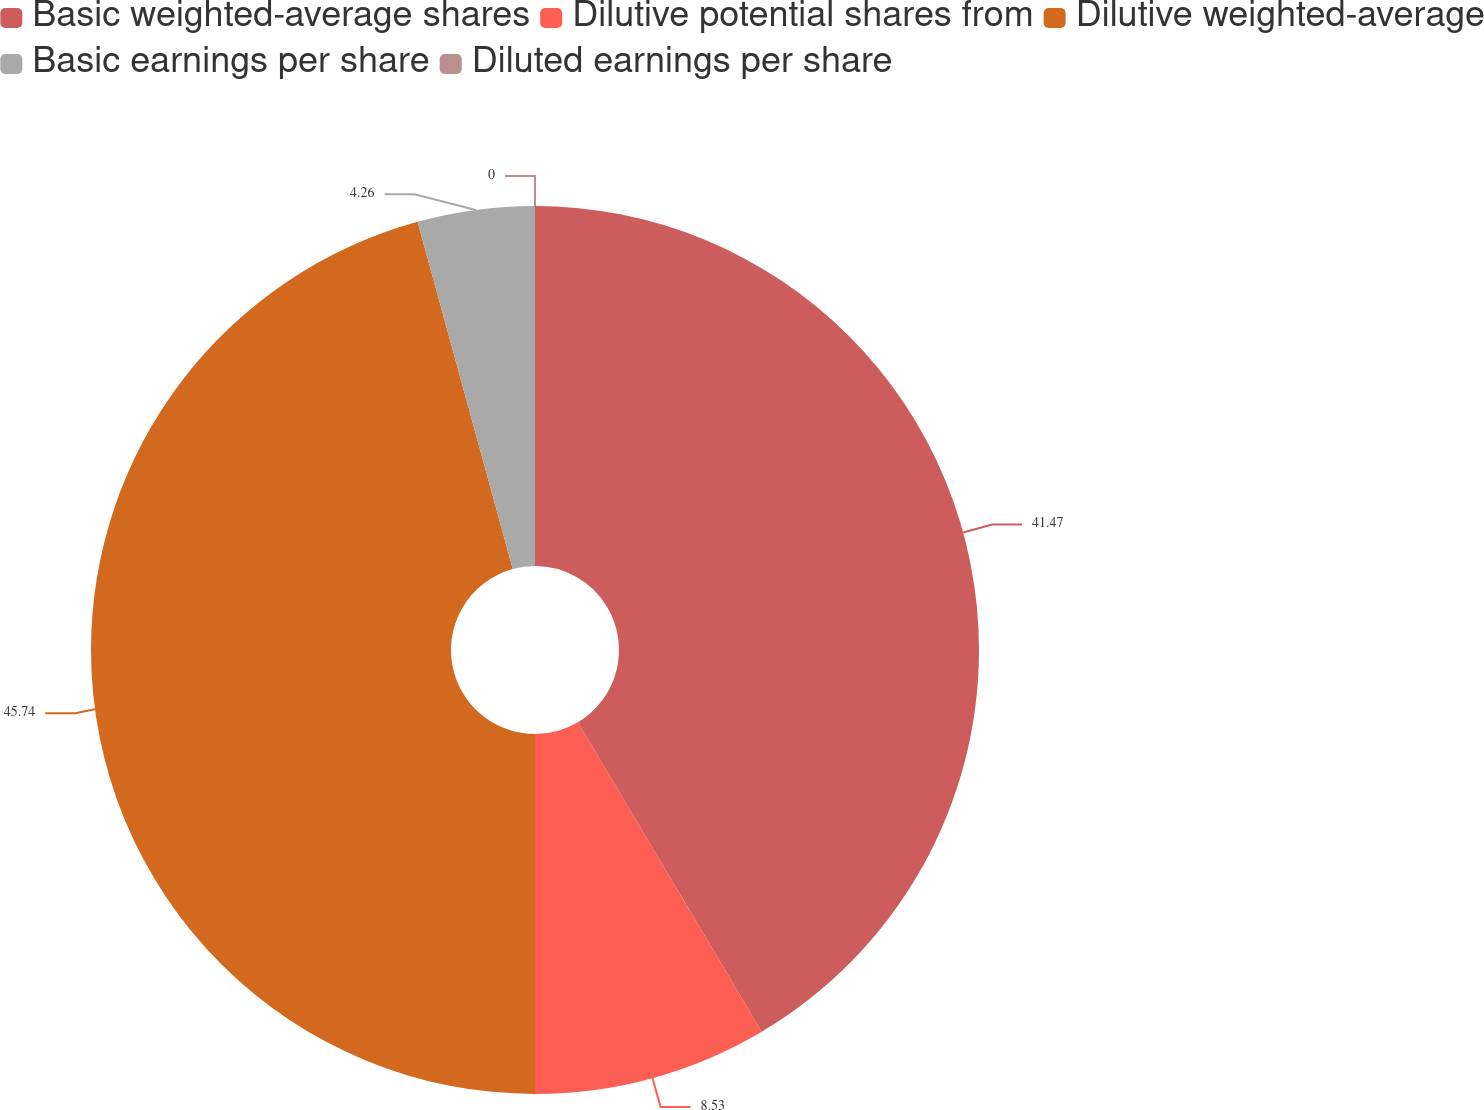Convert chart. <chart><loc_0><loc_0><loc_500><loc_500><pie_chart><fcel>Basic weighted-average shares<fcel>Dilutive potential shares from<fcel>Dilutive weighted-average<fcel>Basic earnings per share<fcel>Diluted earnings per share<nl><fcel>41.47%<fcel>8.53%<fcel>45.74%<fcel>4.26%<fcel>0.0%<nl></chart> 